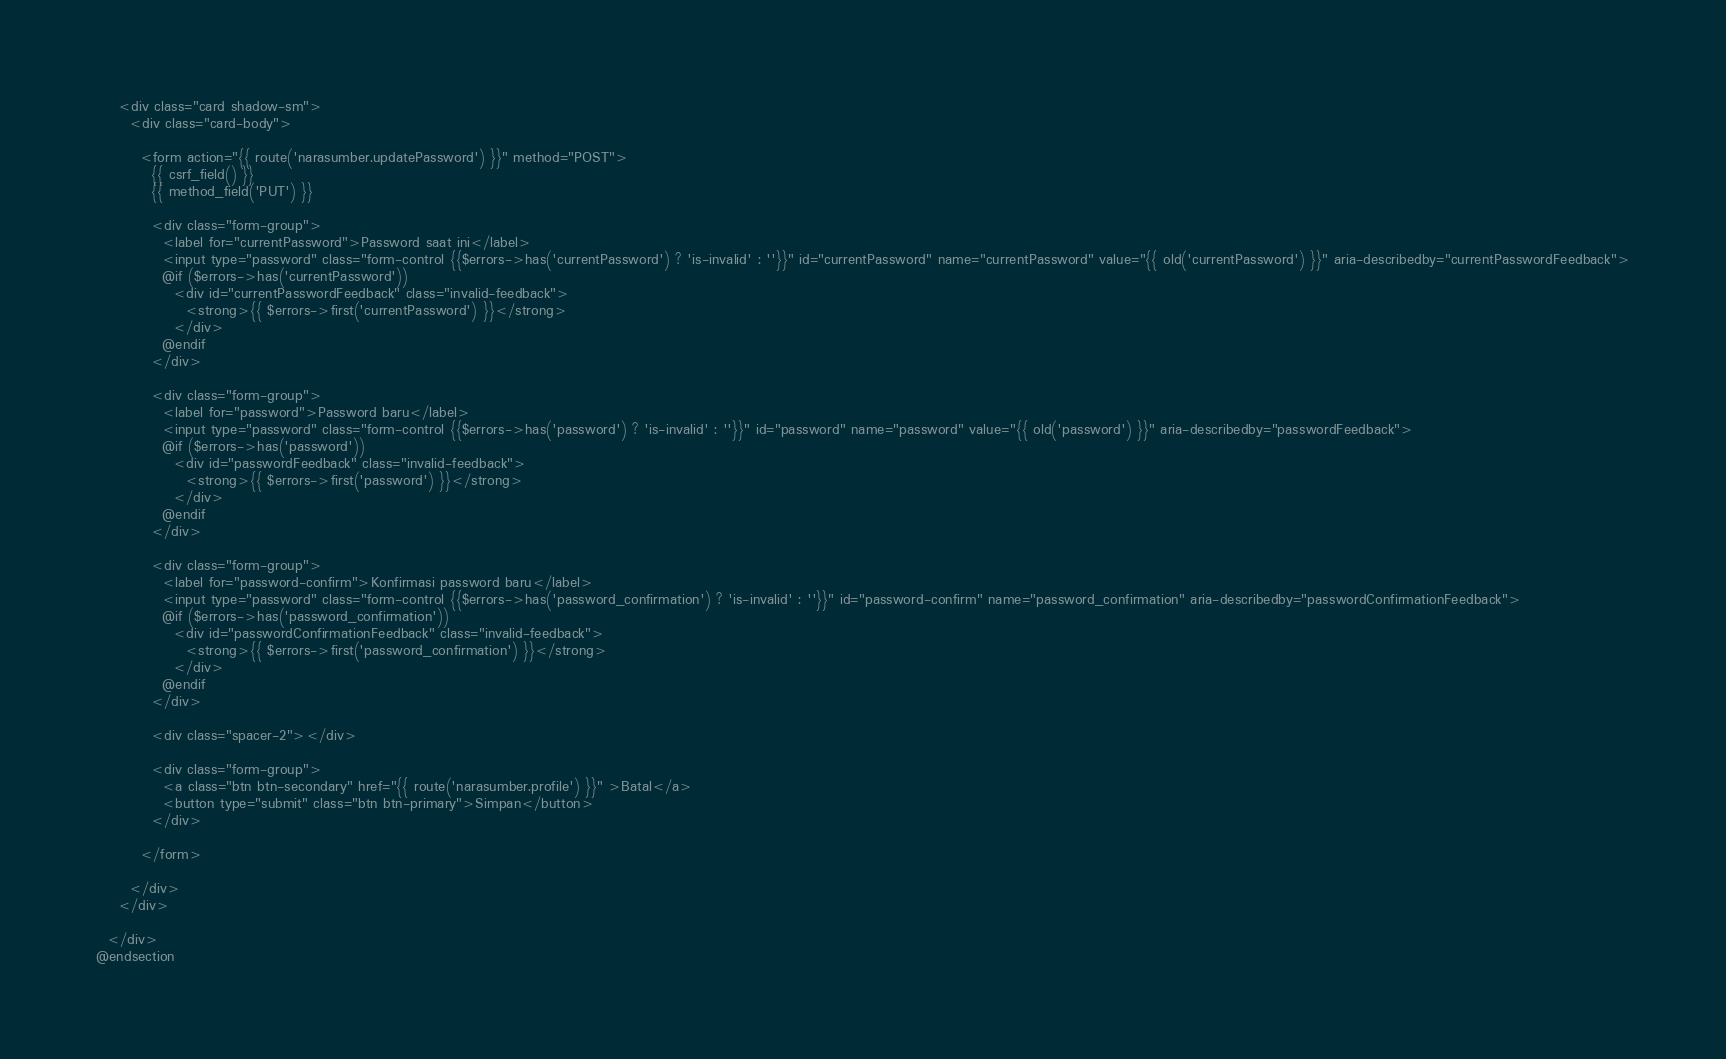Convert code to text. <code><loc_0><loc_0><loc_500><loc_500><_PHP_>
    <div class="card shadow-sm">
      <div class="card-body">

        <form action="{{ route('narasumber.updatePassword') }}" method="POST">
          {{ csrf_field() }}
          {{ method_field('PUT') }}

          <div class="form-group">
            <label for="currentPassword">Password saat ini</label>
            <input type="password" class="form-control {{$errors->has('currentPassword') ? 'is-invalid' : ''}}" id="currentPassword" name="currentPassword" value="{{ old('currentPassword') }}" aria-describedby="currentPasswordFeedback">
            @if ($errors->has('currentPassword'))
              <div id="currentPasswordFeedback" class="invalid-feedback">
                <strong>{{ $errors->first('currentPassword') }}</strong>
              </div>
            @endif
          </div>

          <div class="form-group">
            <label for="password">Password baru</label>
            <input type="password" class="form-control {{$errors->has('password') ? 'is-invalid' : ''}}" id="password" name="password" value="{{ old('password') }}" aria-describedby="passwordFeedback">
            @if ($errors->has('password'))
              <div id="passwordFeedback" class="invalid-feedback">
                <strong>{{ $errors->first('password') }}</strong>
              </div>
            @endif
          </div>
    
          <div class="form-group">
            <label for="password-confirm">Konfirmasi password baru</label>
            <input type="password" class="form-control {{$errors->has('password_confirmation') ? 'is-invalid' : ''}}" id="password-confirm" name="password_confirmation" aria-describedby="passwordConfirmationFeedback">
            @if ($errors->has('password_confirmation'))
              <div id="passwordConfirmationFeedback" class="invalid-feedback">
                <strong>{{ $errors->first('password_confirmation') }}</strong>
              </div>
            @endif
          </div>

          <div class="spacer-2"></div>
    
          <div class="form-group">
            <a class="btn btn-secondary" href="{{ route('narasumber.profile') }}" >Batal</a>
            <button type="submit" class="btn btn-primary">Simpan</button>
          </div>
          
        </form>

      </div>
    </div>

  </div>
@endsection</code> 